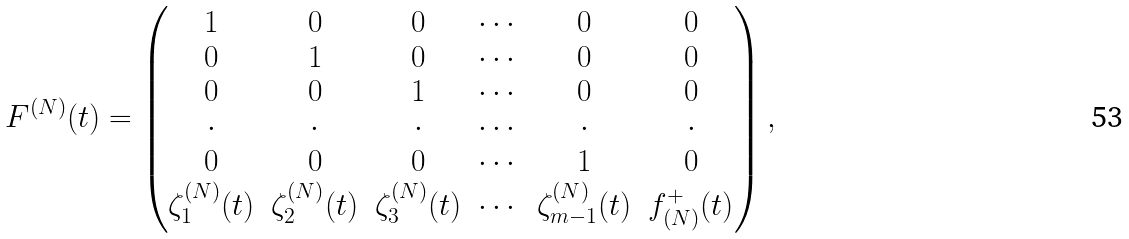Convert formula to latex. <formula><loc_0><loc_0><loc_500><loc_500>F ^ { ( N ) } ( t ) = \begin{pmatrix} 1 & 0 & 0 & \cdots & 0 & 0 \\ 0 & 1 & 0 & \cdots & 0 & 0 \\ 0 & 0 & 1 & \cdots & 0 & 0 \\ \cdot & \cdot & \cdot & \cdots & \cdot & \cdot \\ 0 & 0 & 0 & \cdots & 1 & 0 \\ \zeta _ { 1 } ^ { ( N ) } ( t ) & \zeta _ { 2 } ^ { ( N ) } ( t ) & \zeta _ { 3 } ^ { ( N ) } ( t ) & \cdots & \zeta _ { m - 1 } ^ { ( N ) } ( t ) & f _ { ( N ) } ^ { + } ( t ) \end{pmatrix} ,</formula> 